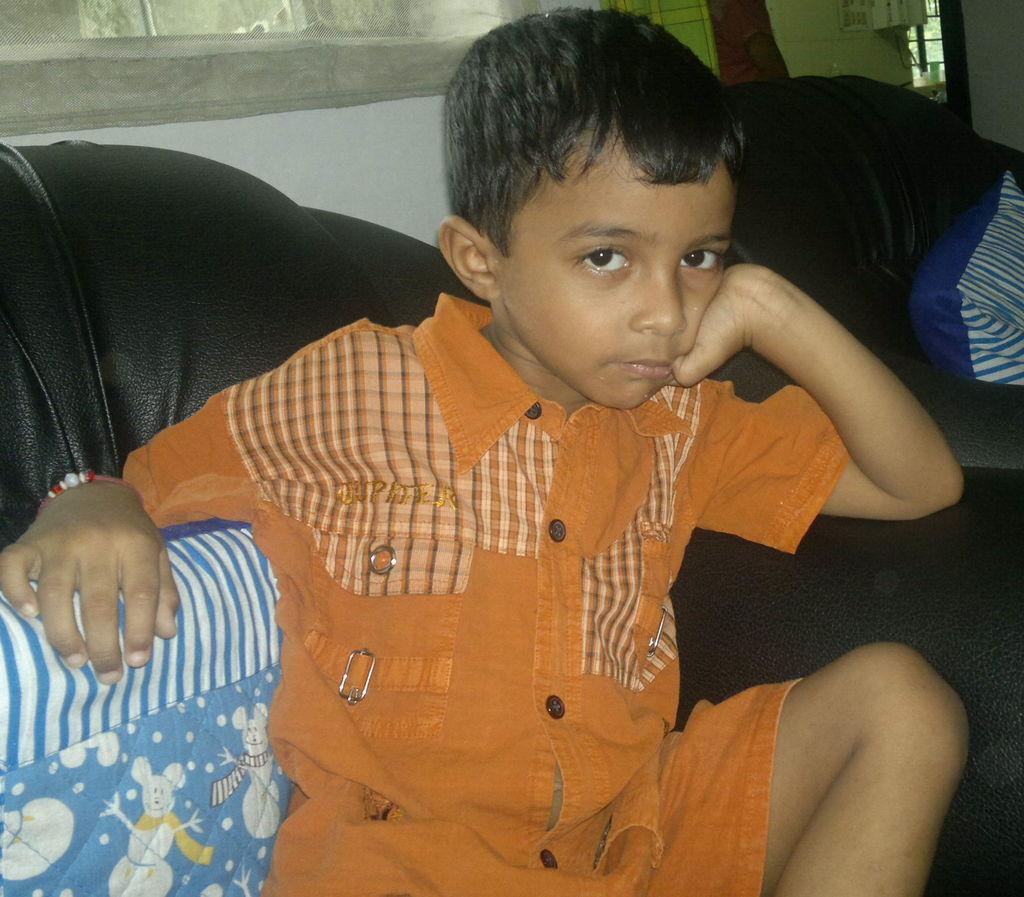What is the main subject of the picture? The main subject of the picture is a child. Where is the child located in the image? The child is sitting on a sofa. In which direction is the child looking? The child is looking towards the front side. What type of jellyfish can be seen swimming in the picture? There is no jellyfish present in the image; it features a child sitting on a sofa. How many tomatoes are visible on the sofa with the child? There are no tomatoes present in the image. 